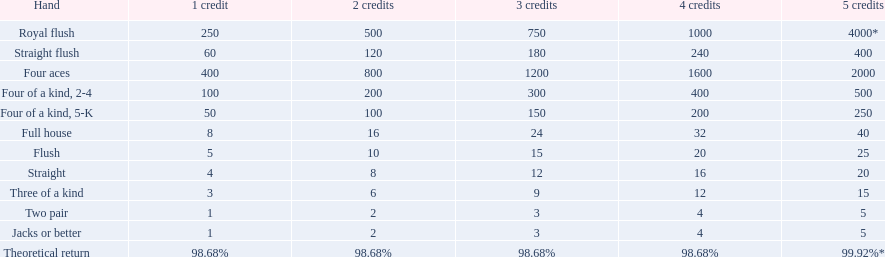What is the higher amount of points for one credit you can get from the best four of a kind 100. What type is it? Four of a kind, 2-4. 